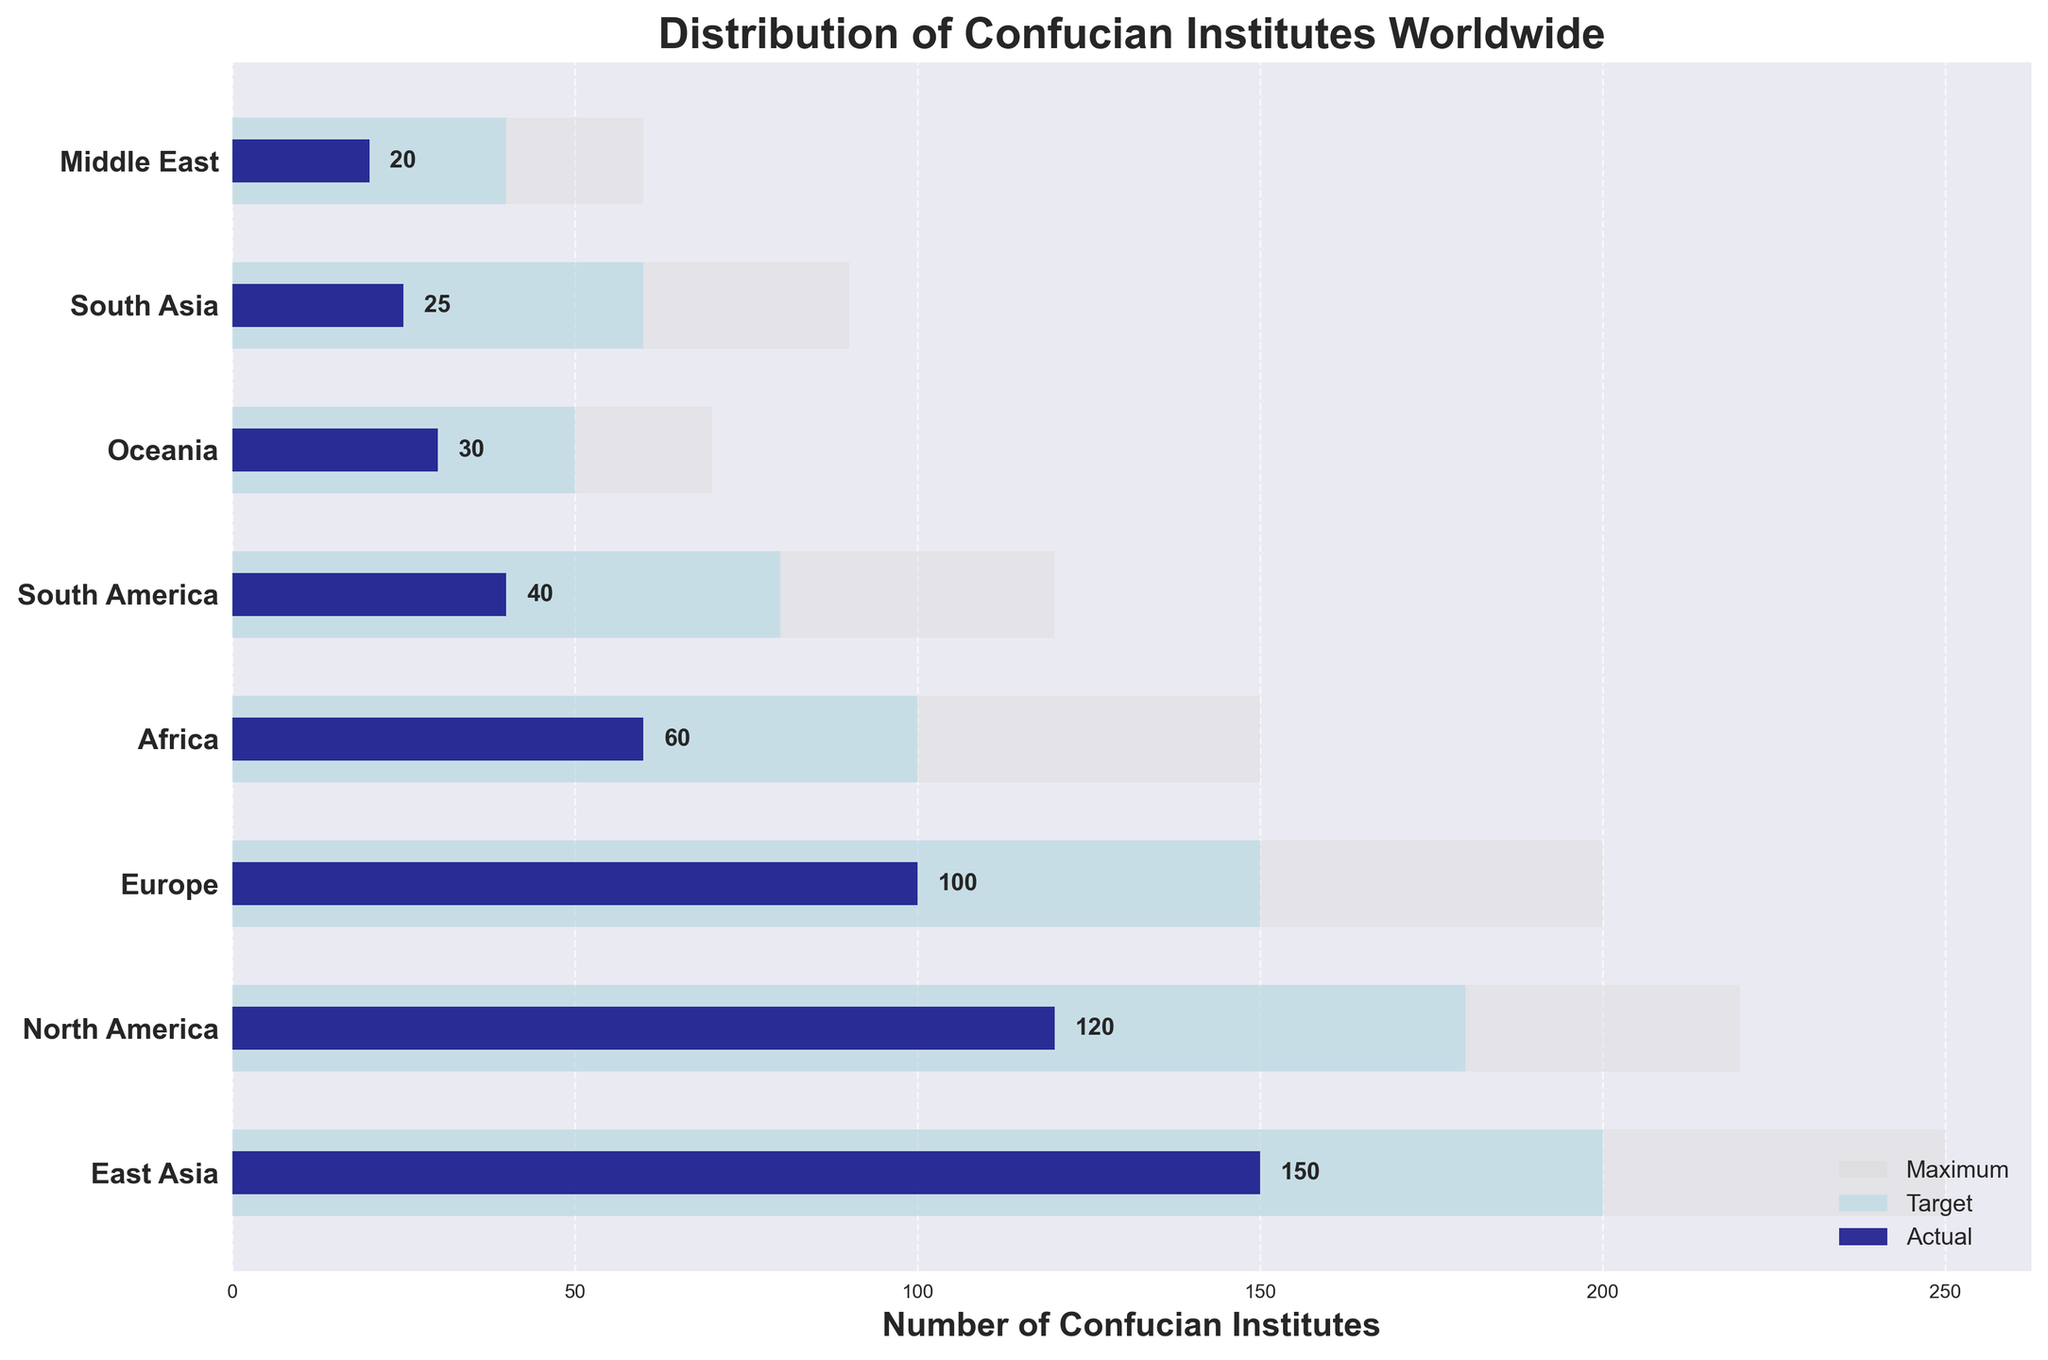Which region has the highest number of Confucian institutes? The bar representing East Asia is the tallest among all the plotted regions.
Answer: East Asia For North America, how does the actual number of Confucian institutes compare to its target? The actual number for North America is represented by the dark blue bar, which is noticeably shorter than the target bar (light blue).
Answer: Below target How many more Confucian institutes are needed in Africa to meet the target? The target for Africa is 100 while the actual value is 60. Subtract the actual from the target: 100 - 60 = 40.
Answer: 40 Which region has the smallest discrepancy between the actual and target numbers of Confucian institutes? Calculating the difference for each region and comparing: East Asia (50), North America (60), Europe (50), Africa (40), South America (40), Oceania (20), South Asia (35), Middle East (20). The smallest discrepancies are in Oceania and the Middle East (20 each).
Answer: Oceania; Middle East What is the total number of Confucian institutes across all regions? Adding the actual numbers for all regions: 150 + 120 + 100 + 60 + 40 + 30 + 25 + 20 = 545.
Answer: 545 Which regions have achieved at least half of their target number of Confucian institutes? Checking if actual numbers are at least half of the targets: East Asia (150 >= 100), North America (120 >= 90), Europe (100 >= 75), Africa (60 >= 50), South America (40 >= 40), Oceania (30 >= 25), South Asia (25 < 30), Middle East (20 < 20). The regions that achieved at least half are East Asia, North America, Europe, Africa, South America, and Oceania.
Answer: East Asia; North America; Europe; Africa; South America; Oceania Between East Asia and Europe, which region is closer to its maximum number of Confucian institutes? For East Asia, the actual number (150) is compared to its maximum (250). For Europe, the actual number (100) is compared to its maximum (200). The percentages for closeness are 150/250 = 60% for East Asia and 100/200 = 50% for Europe.
Answer: East Asia What is the overall percentage achieved toward the target number of institutes in South America? The actual number (40) divided by the target number (80) multiplied by 100 for percentage: (40 / 80) * 100 = 50%.
Answer: 50% Which two regions have the largest gaps between their actual and maximum numbers of Confucian institutes? Calculating the gaps for all regions: East Asia (250 - 150 = 100), North America (220 - 120 = 100), Europe (200 - 100 = 100), Africa (150 - 60 = 90), South America (120 - 40 = 80), Oceania (70 - 30 = 40), South Asia (90 - 25 = 65), Middle East (60 - 20 = 40). The largest gaps are in East Asia, North America, and Europe (each 100).
Answer: East Asia; North America; Europe Are there any regions where the actual number of institutes exceeds the target number? Check if any actual values are greater than their corresponding target values: since all actual bars are shorter than target bars, there are no regions exceeding targets.
Answer: No 